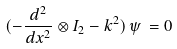Convert formula to latex. <formula><loc_0><loc_0><loc_500><loc_500>( - \frac { d ^ { 2 } } { d x ^ { 2 } } \otimes I _ { 2 } - k ^ { 2 } ) \, \psi \, = 0</formula> 